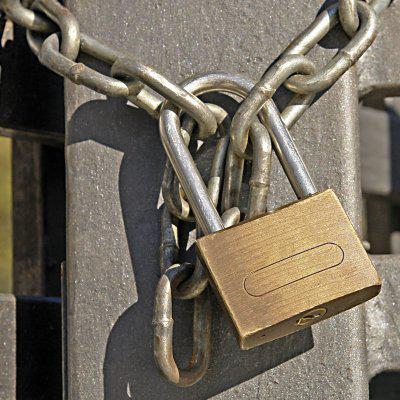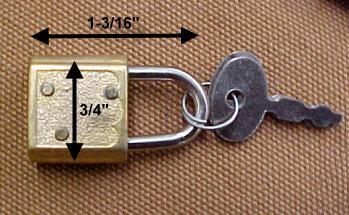The first image is the image on the left, the second image is the image on the right. Given the left and right images, does the statement "An image shows one lock with two keys inserted into it." hold true? Answer yes or no. No. 